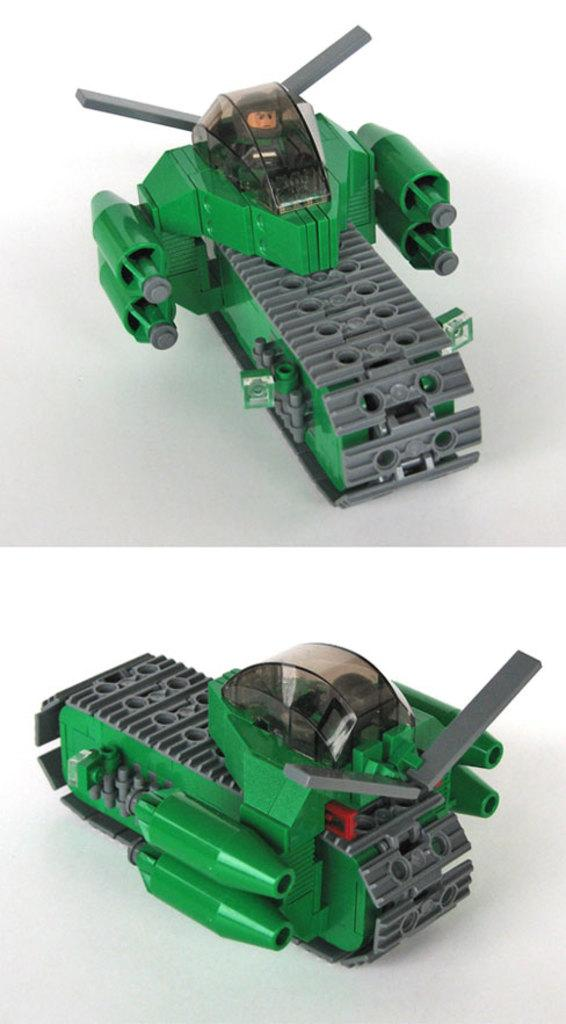What type of image is being described? The image is a collage. What objects can be seen in the collage? There are toys in the image. What colors are the toys? The toys are in green and grey colors. What is the background color of the collage? There is a white background in the image. What type of chin can be seen in the image? There is no chin present in the image, as it is a collage of toys and does not depict any human or animal faces. 